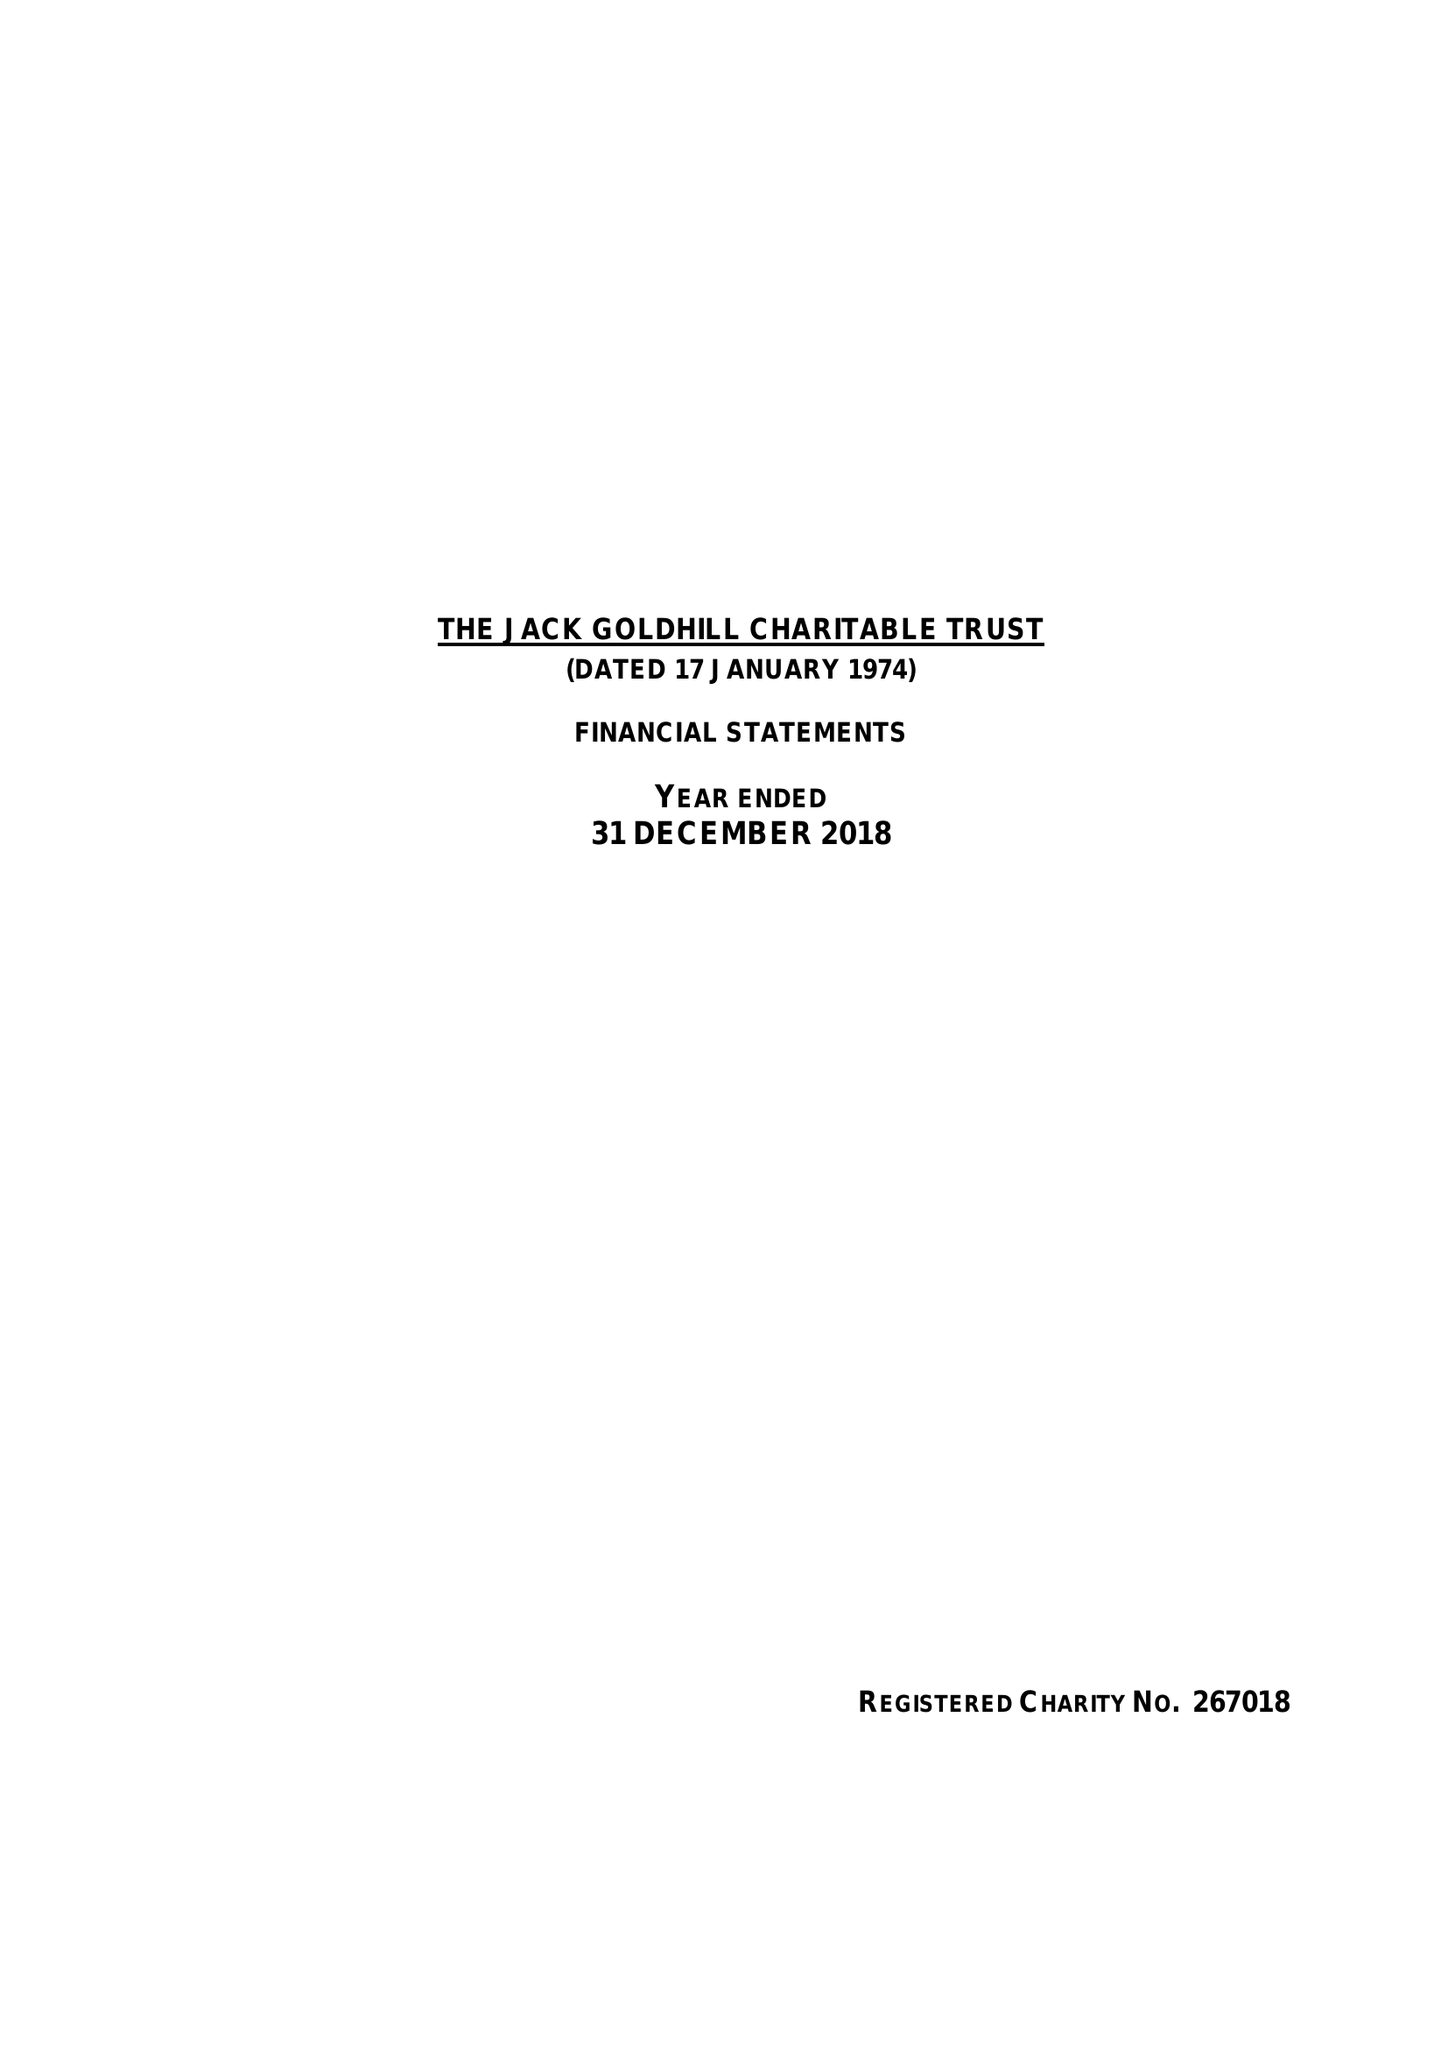What is the value for the income_annually_in_british_pounds?
Answer the question using a single word or phrase. 123661.00 